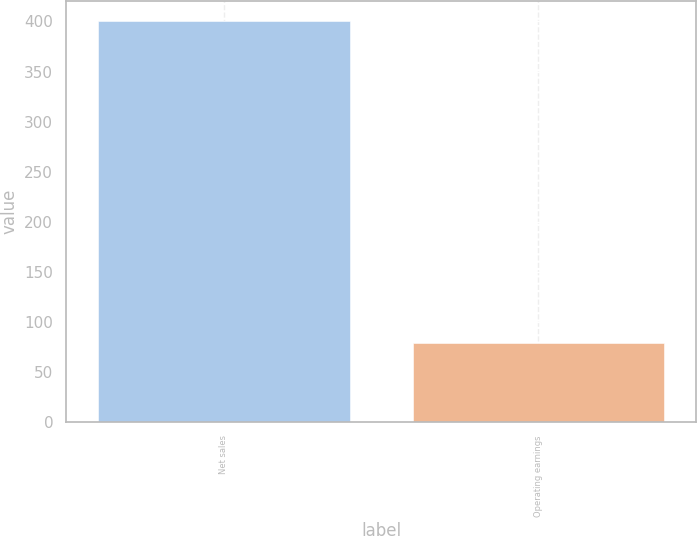<chart> <loc_0><loc_0><loc_500><loc_500><bar_chart><fcel>Net sales<fcel>Operating earnings<nl><fcel>400<fcel>79<nl></chart> 